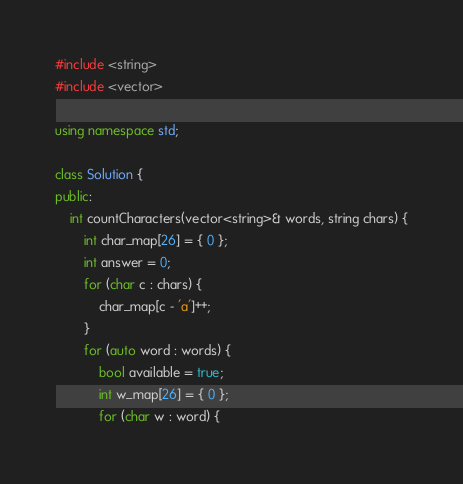Convert code to text. <code><loc_0><loc_0><loc_500><loc_500><_C++_>#include <string>
#include <vector>

using namespace std;

class Solution {
public:
	int countCharacters(vector<string>& words, string chars) {
		int char_map[26] = { 0 };
		int answer = 0;
		for (char c : chars) {
			char_map[c - 'a']++;
		}
		for (auto word : words) {
			bool available = true;
			int w_map[26] = { 0 };
			for (char w : word) {</code> 